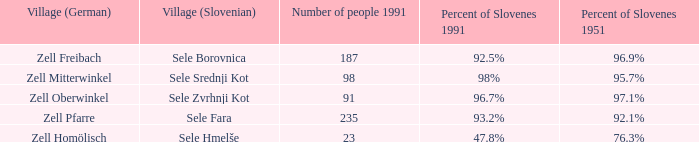Provide me with the name of all the village (German) that are part of the village (Slovenian) with sele borovnica. Zell Freibach. 